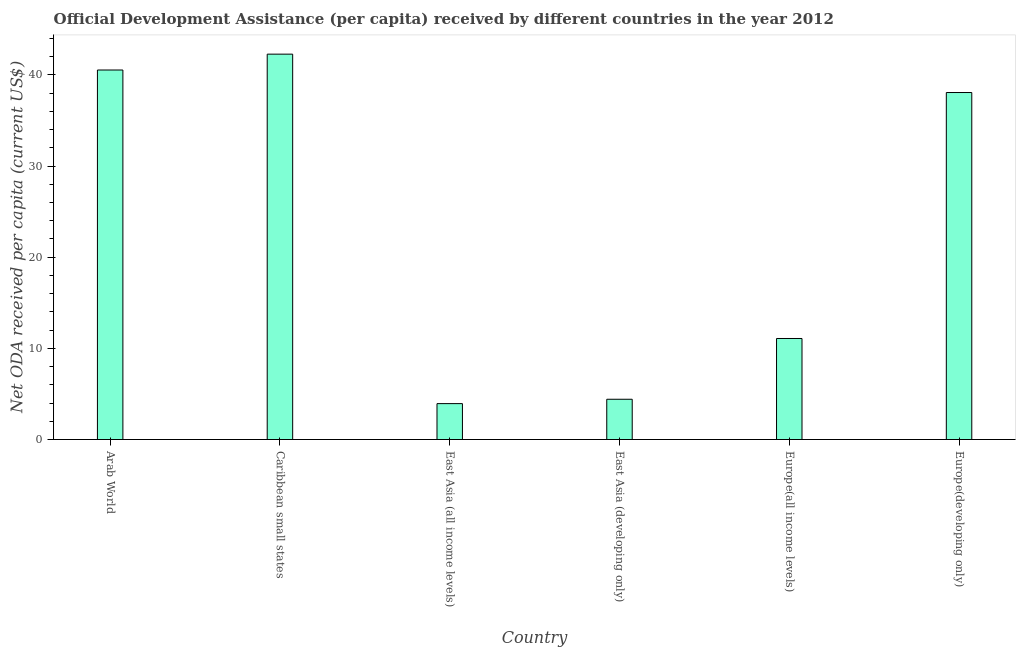Does the graph contain any zero values?
Give a very brief answer. No. Does the graph contain grids?
Offer a very short reply. No. What is the title of the graph?
Offer a very short reply. Official Development Assistance (per capita) received by different countries in the year 2012. What is the label or title of the X-axis?
Keep it short and to the point. Country. What is the label or title of the Y-axis?
Offer a terse response. Net ODA received per capita (current US$). What is the net oda received per capita in Europe(developing only)?
Keep it short and to the point. 38.06. Across all countries, what is the maximum net oda received per capita?
Make the answer very short. 42.27. Across all countries, what is the minimum net oda received per capita?
Your response must be concise. 3.94. In which country was the net oda received per capita maximum?
Offer a very short reply. Caribbean small states. In which country was the net oda received per capita minimum?
Provide a succinct answer. East Asia (all income levels). What is the sum of the net oda received per capita?
Give a very brief answer. 140.3. What is the difference between the net oda received per capita in Europe(all income levels) and Europe(developing only)?
Your answer should be compact. -26.98. What is the average net oda received per capita per country?
Make the answer very short. 23.38. What is the median net oda received per capita?
Provide a short and direct response. 24.57. What is the ratio of the net oda received per capita in East Asia (all income levels) to that in Europe(all income levels)?
Give a very brief answer. 0.35. Is the difference between the net oda received per capita in Caribbean small states and Europe(developing only) greater than the difference between any two countries?
Your answer should be compact. No. What is the difference between the highest and the second highest net oda received per capita?
Provide a succinct answer. 1.74. Is the sum of the net oda received per capita in Arab World and Europe(all income levels) greater than the maximum net oda received per capita across all countries?
Offer a terse response. Yes. What is the difference between the highest and the lowest net oda received per capita?
Provide a short and direct response. 38.34. How many bars are there?
Give a very brief answer. 6. Are the values on the major ticks of Y-axis written in scientific E-notation?
Your answer should be very brief. No. What is the Net ODA received per capita (current US$) of Arab World?
Your answer should be compact. 40.53. What is the Net ODA received per capita (current US$) of Caribbean small states?
Your answer should be compact. 42.27. What is the Net ODA received per capita (current US$) of East Asia (all income levels)?
Keep it short and to the point. 3.94. What is the Net ODA received per capita (current US$) of East Asia (developing only)?
Your answer should be very brief. 4.42. What is the Net ODA received per capita (current US$) of Europe(all income levels)?
Your response must be concise. 11.08. What is the Net ODA received per capita (current US$) in Europe(developing only)?
Offer a terse response. 38.06. What is the difference between the Net ODA received per capita (current US$) in Arab World and Caribbean small states?
Offer a very short reply. -1.74. What is the difference between the Net ODA received per capita (current US$) in Arab World and East Asia (all income levels)?
Make the answer very short. 36.6. What is the difference between the Net ODA received per capita (current US$) in Arab World and East Asia (developing only)?
Your response must be concise. 36.12. What is the difference between the Net ODA received per capita (current US$) in Arab World and Europe(all income levels)?
Make the answer very short. 29.45. What is the difference between the Net ODA received per capita (current US$) in Arab World and Europe(developing only)?
Offer a very short reply. 2.47. What is the difference between the Net ODA received per capita (current US$) in Caribbean small states and East Asia (all income levels)?
Provide a short and direct response. 38.34. What is the difference between the Net ODA received per capita (current US$) in Caribbean small states and East Asia (developing only)?
Offer a very short reply. 37.86. What is the difference between the Net ODA received per capita (current US$) in Caribbean small states and Europe(all income levels)?
Offer a terse response. 31.19. What is the difference between the Net ODA received per capita (current US$) in Caribbean small states and Europe(developing only)?
Provide a succinct answer. 4.21. What is the difference between the Net ODA received per capita (current US$) in East Asia (all income levels) and East Asia (developing only)?
Your response must be concise. -0.48. What is the difference between the Net ODA received per capita (current US$) in East Asia (all income levels) and Europe(all income levels)?
Offer a terse response. -7.14. What is the difference between the Net ODA received per capita (current US$) in East Asia (all income levels) and Europe(developing only)?
Make the answer very short. -34.13. What is the difference between the Net ODA received per capita (current US$) in East Asia (developing only) and Europe(all income levels)?
Your response must be concise. -6.66. What is the difference between the Net ODA received per capita (current US$) in East Asia (developing only) and Europe(developing only)?
Make the answer very short. -33.65. What is the difference between the Net ODA received per capita (current US$) in Europe(all income levels) and Europe(developing only)?
Your answer should be compact. -26.98. What is the ratio of the Net ODA received per capita (current US$) in Arab World to that in East Asia (all income levels)?
Your response must be concise. 10.29. What is the ratio of the Net ODA received per capita (current US$) in Arab World to that in East Asia (developing only)?
Give a very brief answer. 9.18. What is the ratio of the Net ODA received per capita (current US$) in Arab World to that in Europe(all income levels)?
Keep it short and to the point. 3.66. What is the ratio of the Net ODA received per capita (current US$) in Arab World to that in Europe(developing only)?
Offer a very short reply. 1.06. What is the ratio of the Net ODA received per capita (current US$) in Caribbean small states to that in East Asia (all income levels)?
Ensure brevity in your answer.  10.74. What is the ratio of the Net ODA received per capita (current US$) in Caribbean small states to that in East Asia (developing only)?
Offer a very short reply. 9.57. What is the ratio of the Net ODA received per capita (current US$) in Caribbean small states to that in Europe(all income levels)?
Your answer should be very brief. 3.81. What is the ratio of the Net ODA received per capita (current US$) in Caribbean small states to that in Europe(developing only)?
Offer a very short reply. 1.11. What is the ratio of the Net ODA received per capita (current US$) in East Asia (all income levels) to that in East Asia (developing only)?
Offer a very short reply. 0.89. What is the ratio of the Net ODA received per capita (current US$) in East Asia (all income levels) to that in Europe(all income levels)?
Ensure brevity in your answer.  0.35. What is the ratio of the Net ODA received per capita (current US$) in East Asia (all income levels) to that in Europe(developing only)?
Provide a succinct answer. 0.1. What is the ratio of the Net ODA received per capita (current US$) in East Asia (developing only) to that in Europe(all income levels)?
Keep it short and to the point. 0.4. What is the ratio of the Net ODA received per capita (current US$) in East Asia (developing only) to that in Europe(developing only)?
Your response must be concise. 0.12. What is the ratio of the Net ODA received per capita (current US$) in Europe(all income levels) to that in Europe(developing only)?
Provide a succinct answer. 0.29. 